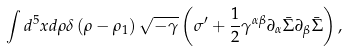<formula> <loc_0><loc_0><loc_500><loc_500>\int { d ^ { 5 } x d \rho \delta \left ( { \rho - \rho _ { 1 } } \right ) \sqrt { - \gamma } \left ( { \sigma ^ { \prime } + \frac { 1 } { 2 } \gamma ^ { \alpha \beta } \partial _ { \alpha } \bar { \Sigma } \partial _ { \beta } \bar { \Sigma } } \right ) } \, ,</formula> 